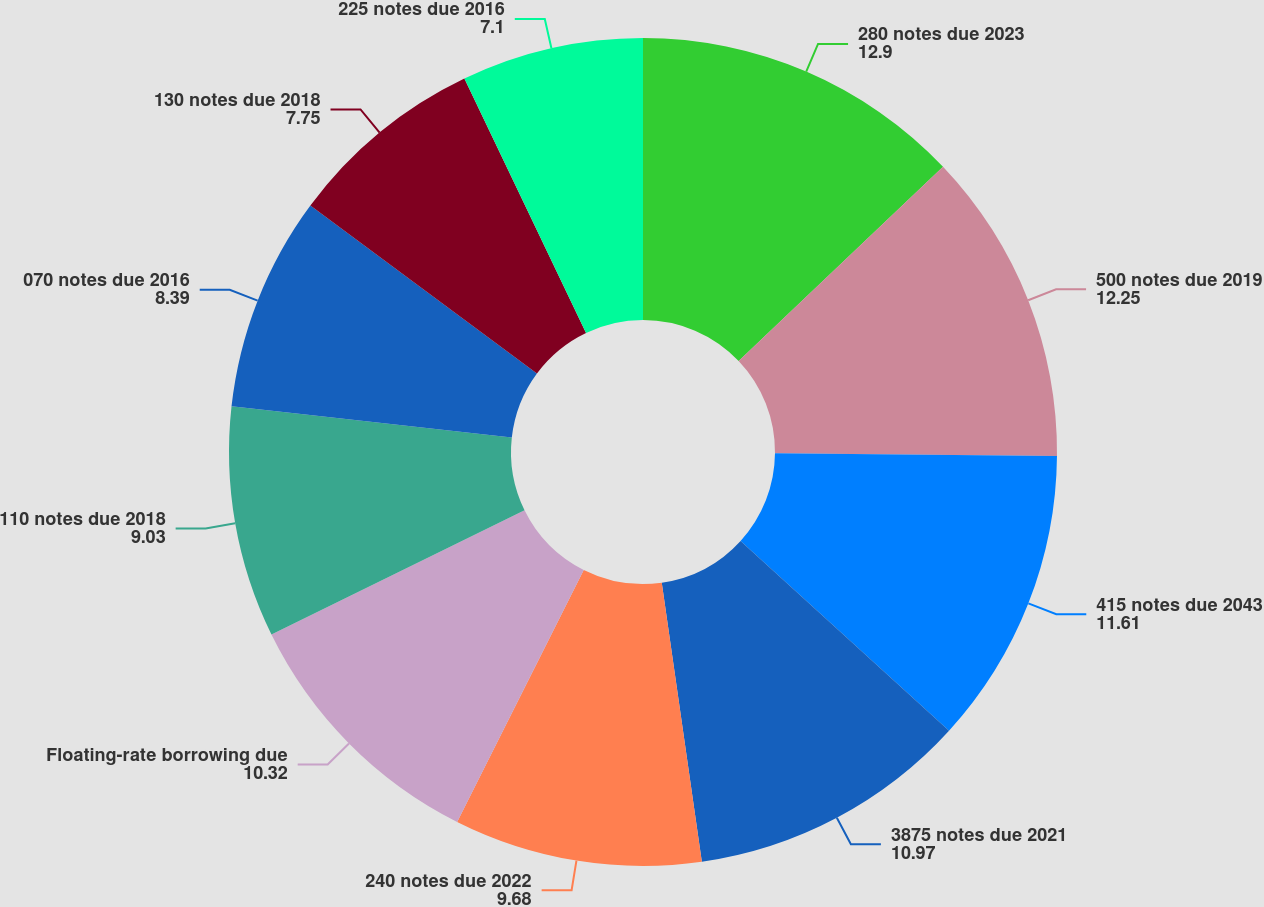<chart> <loc_0><loc_0><loc_500><loc_500><pie_chart><fcel>280 notes due 2023<fcel>500 notes due 2019<fcel>415 notes due 2043<fcel>3875 notes due 2021<fcel>240 notes due 2022<fcel>Floating-rate borrowing due<fcel>110 notes due 2018<fcel>070 notes due 2016<fcel>130 notes due 2018<fcel>225 notes due 2016<nl><fcel>12.9%<fcel>12.25%<fcel>11.61%<fcel>10.97%<fcel>9.68%<fcel>10.32%<fcel>9.03%<fcel>8.39%<fcel>7.75%<fcel>7.1%<nl></chart> 